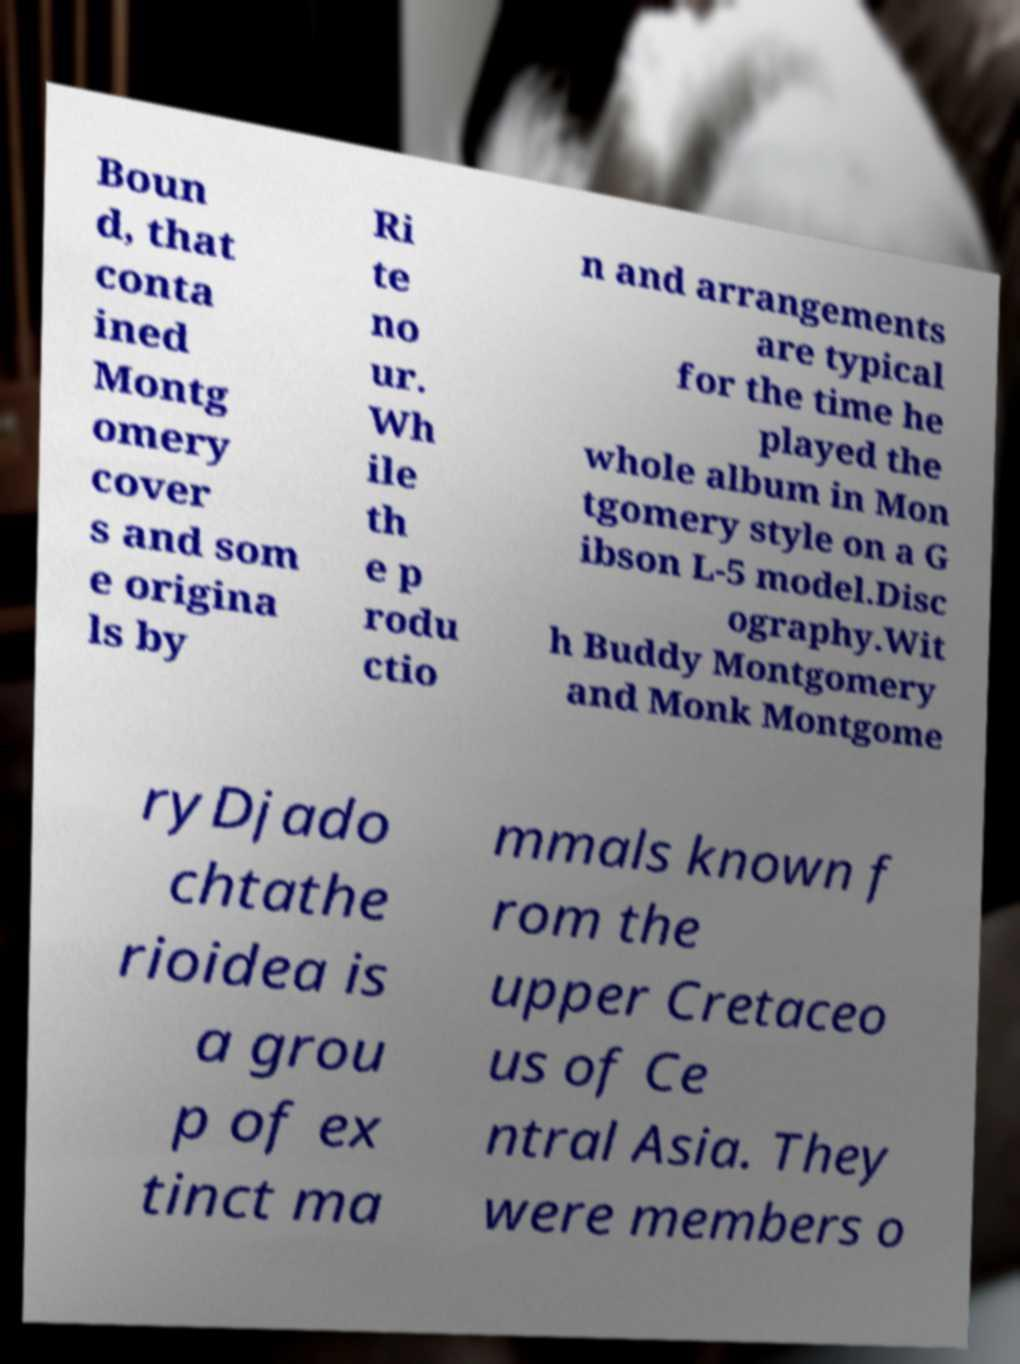Please read and relay the text visible in this image. What does it say? Boun d, that conta ined Montg omery cover s and som e origina ls by Ri te no ur. Wh ile th e p rodu ctio n and arrangements are typical for the time he played the whole album in Mon tgomery style on a G ibson L-5 model.Disc ography.Wit h Buddy Montgomery and Monk Montgome ryDjado chtathe rioidea is a grou p of ex tinct ma mmals known f rom the upper Cretaceo us of Ce ntral Asia. They were members o 